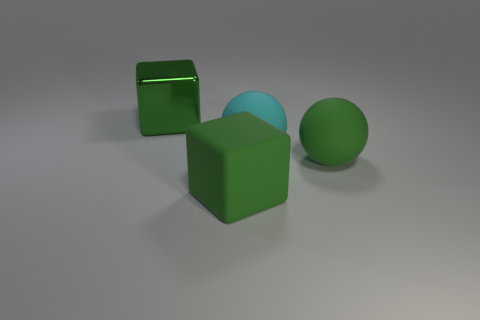Add 3 green blocks. How many objects exist? 7 Subtract 2 green blocks. How many objects are left? 2 Subtract all green shiny blocks. Subtract all large green matte cubes. How many objects are left? 2 Add 3 metal things. How many metal things are left? 4 Add 3 cyan matte objects. How many cyan matte objects exist? 4 